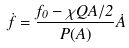<formula> <loc_0><loc_0><loc_500><loc_500>\dot { f } = \frac { f _ { 0 } - \chi Q A / 2 } { P ( A ) } \dot { A }</formula> 